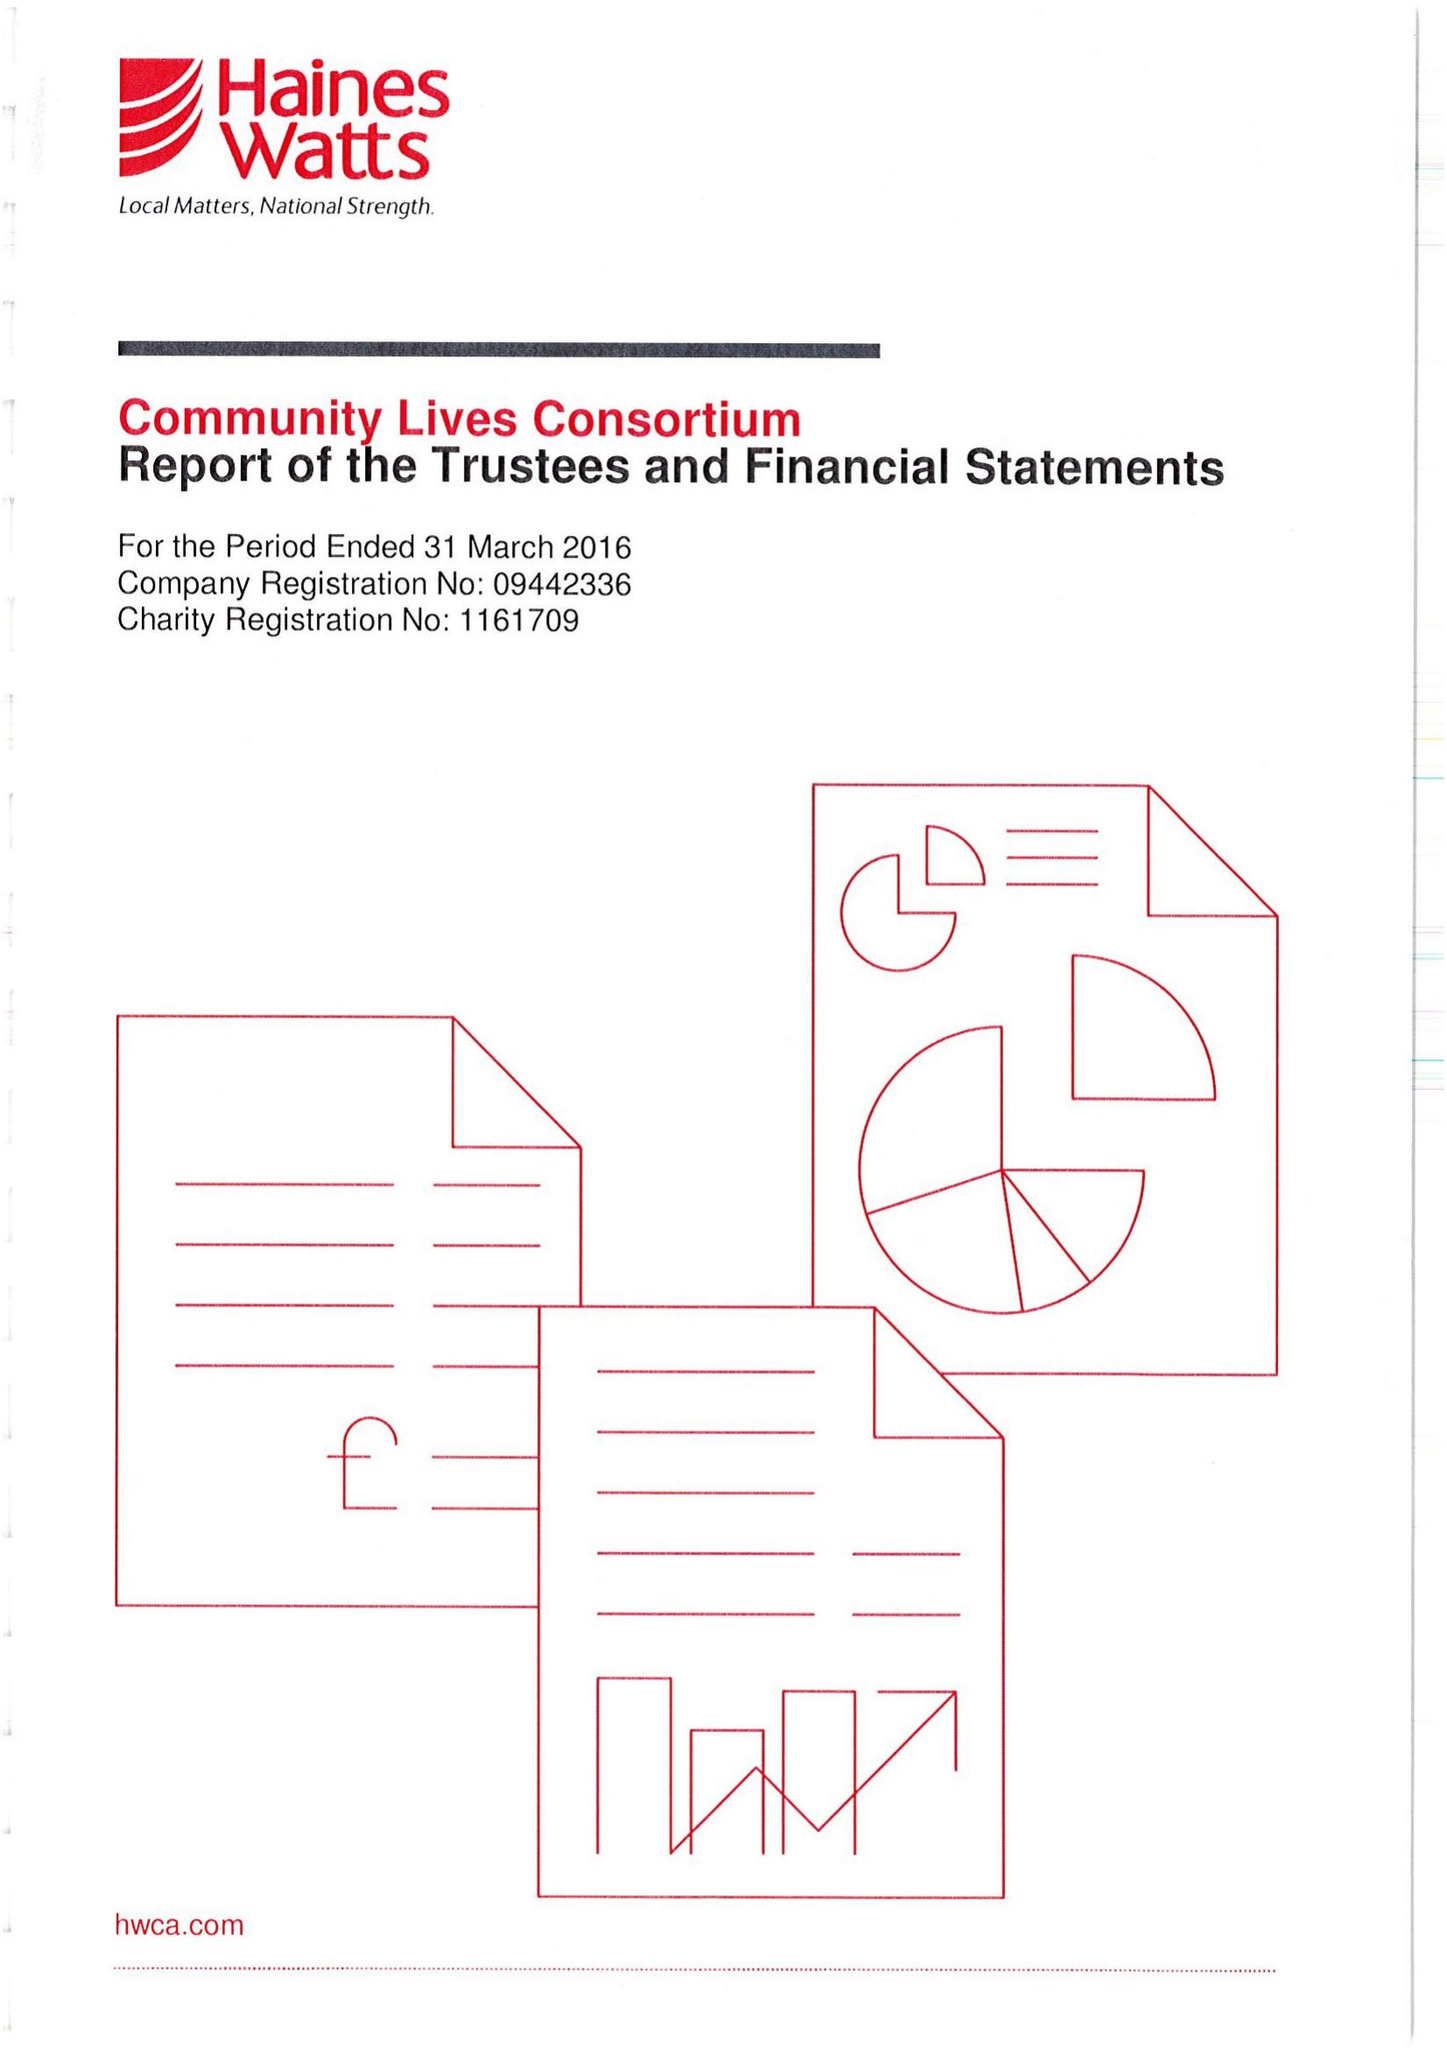What is the value for the income_annually_in_british_pounds?
Answer the question using a single word or phrase. 17177389.00 